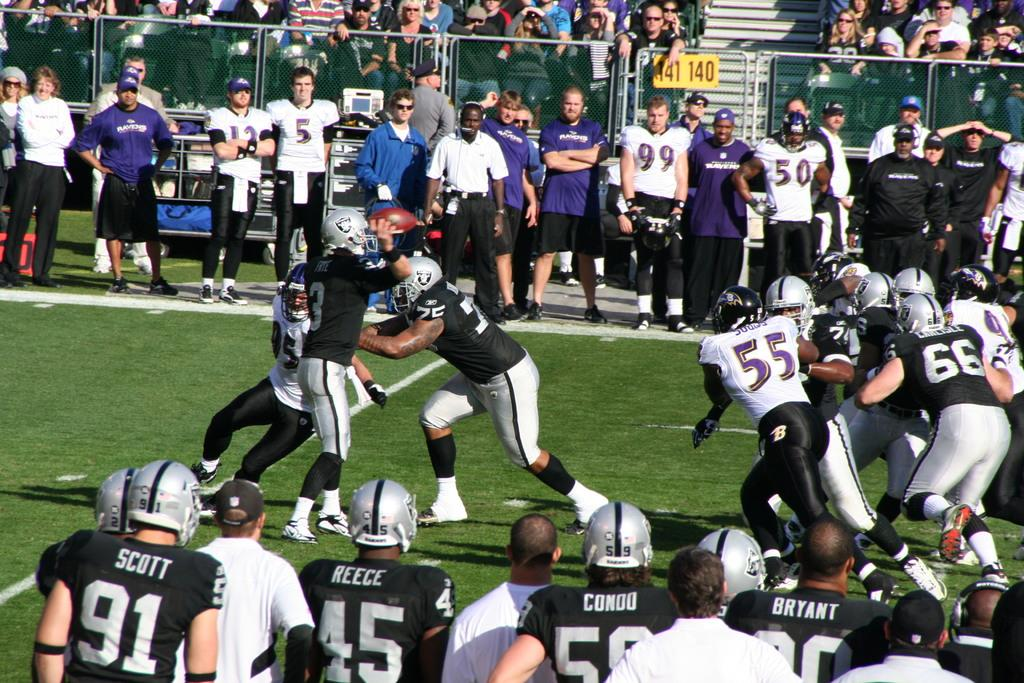What is happening in the image? There is a group of people standing in the image. Can you describe the attire of the people in the image? The people are wearing different color dresses. What is happening in the background of the image? There are people sitting in the background of the image. What can be seen in the image besides the people? There is a fencing and a yellow color board in the image. Can you tell me how many monkeys are sitting on the yellow color board in the image? There are no monkeys present in the image; it only features a group of people and a yellow color board. What type of pickle is being used as a decoration on the people's dresses in the image? There are no pickles present in the image; the people are wearing different color dresses without any decorations mentioned. 